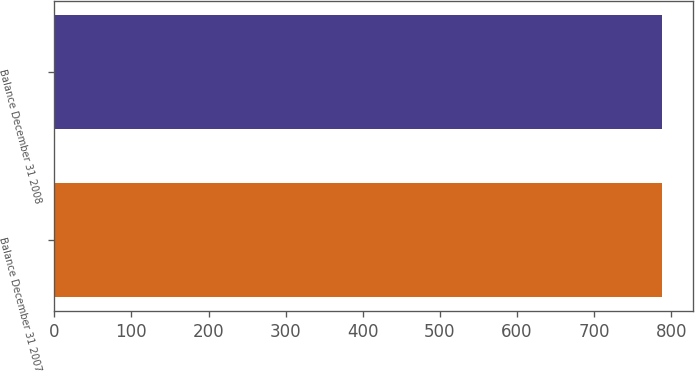<chart> <loc_0><loc_0><loc_500><loc_500><bar_chart><fcel>Balance December 31 2007<fcel>Balance December 31 2008<nl><fcel>788<fcel>788.1<nl></chart> 